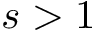Convert formula to latex. <formula><loc_0><loc_0><loc_500><loc_500>s > 1</formula> 